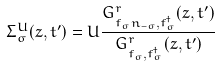<formula> <loc_0><loc_0><loc_500><loc_500>\Sigma ^ { U } _ { \sigma } ( z , t ^ { \prime } ) = U \frac { G ^ { r } _ { f _ { \sigma } n _ { - \sigma } , f ^ { \dagger } _ { \sigma } } ( z , t ^ { \prime } ) } { G ^ { r } _ { f _ { \sigma } , f ^ { \dagger } _ { \sigma } } ( z , t ^ { \prime } ) }</formula> 